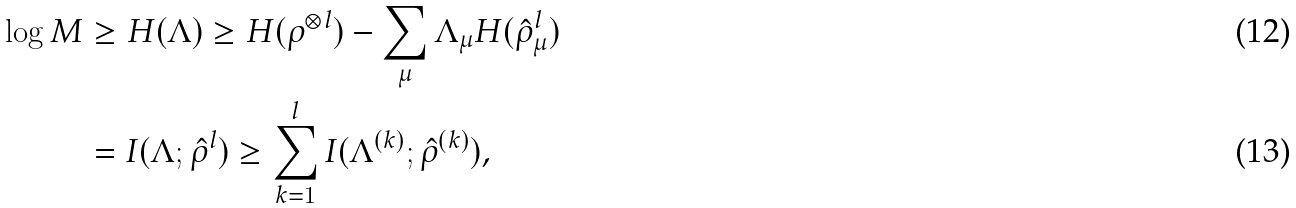<formula> <loc_0><loc_0><loc_500><loc_500>\log M & \geq H ( \Lambda ) \geq H ( \rho ^ { \otimes l } ) - \sum _ { \mu } \Lambda _ { \mu } H ( \hat { \rho } ^ { l } _ { \mu } ) \\ & = I ( \Lambda ; \hat { \rho } ^ { l } ) \geq \sum _ { k = 1 } ^ { l } I ( \Lambda ^ { ( k ) } ; \hat { \rho } ^ { ( k ) } ) ,</formula> 